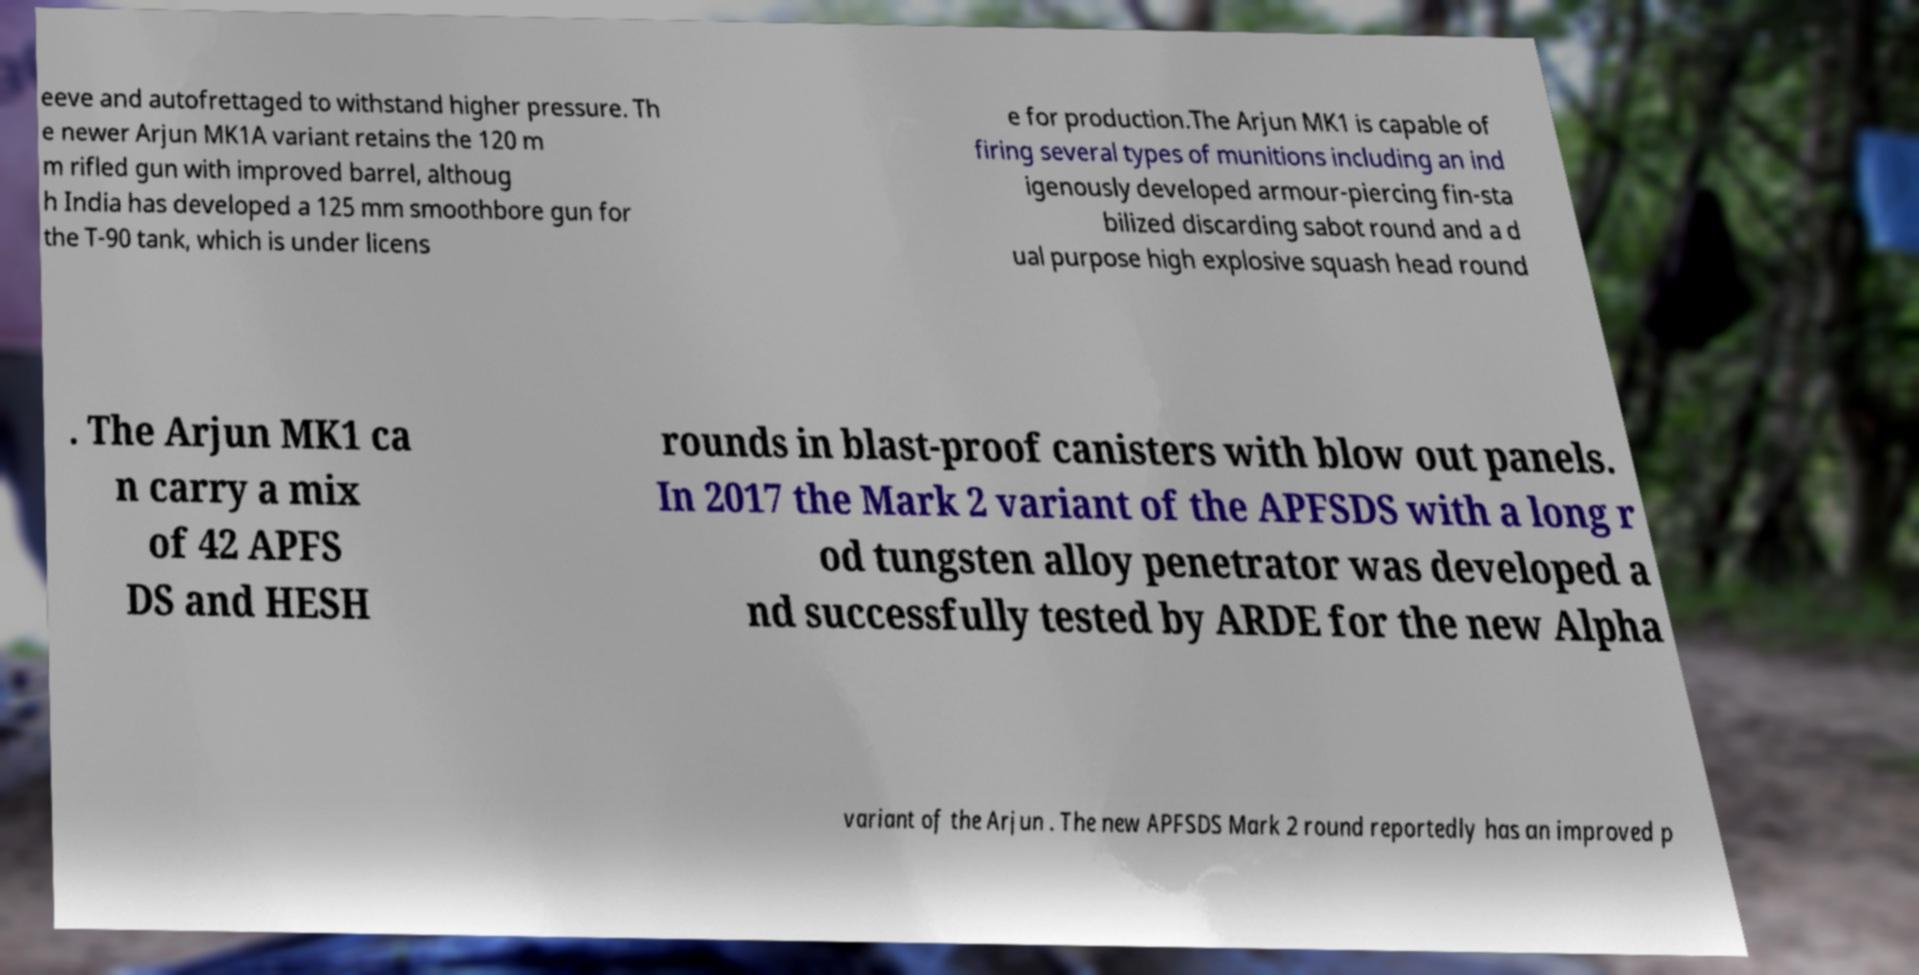Please read and relay the text visible in this image. What does it say? eeve and autofrettaged to withstand higher pressure. Th e newer Arjun MK1A variant retains the 120 m m rifled gun with improved barrel, althoug h India has developed a 125 mm smoothbore gun for the T-90 tank, which is under licens e for production.The Arjun MK1 is capable of firing several types of munitions including an ind igenously developed armour-piercing fin-sta bilized discarding sabot round and a d ual purpose high explosive squash head round . The Arjun MK1 ca n carry a mix of 42 APFS DS and HESH rounds in blast-proof canisters with blow out panels. In 2017 the Mark 2 variant of the APFSDS with a long r od tungsten alloy penetrator was developed a nd successfully tested by ARDE for the new Alpha variant of the Arjun . The new APFSDS Mark 2 round reportedly has an improved p 